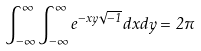<formula> <loc_0><loc_0><loc_500><loc_500>\int _ { - \infty } ^ { \infty } \int _ { - \infty } ^ { \infty } e ^ { - x y \sqrt { - 1 } } d x d y = 2 \pi</formula> 